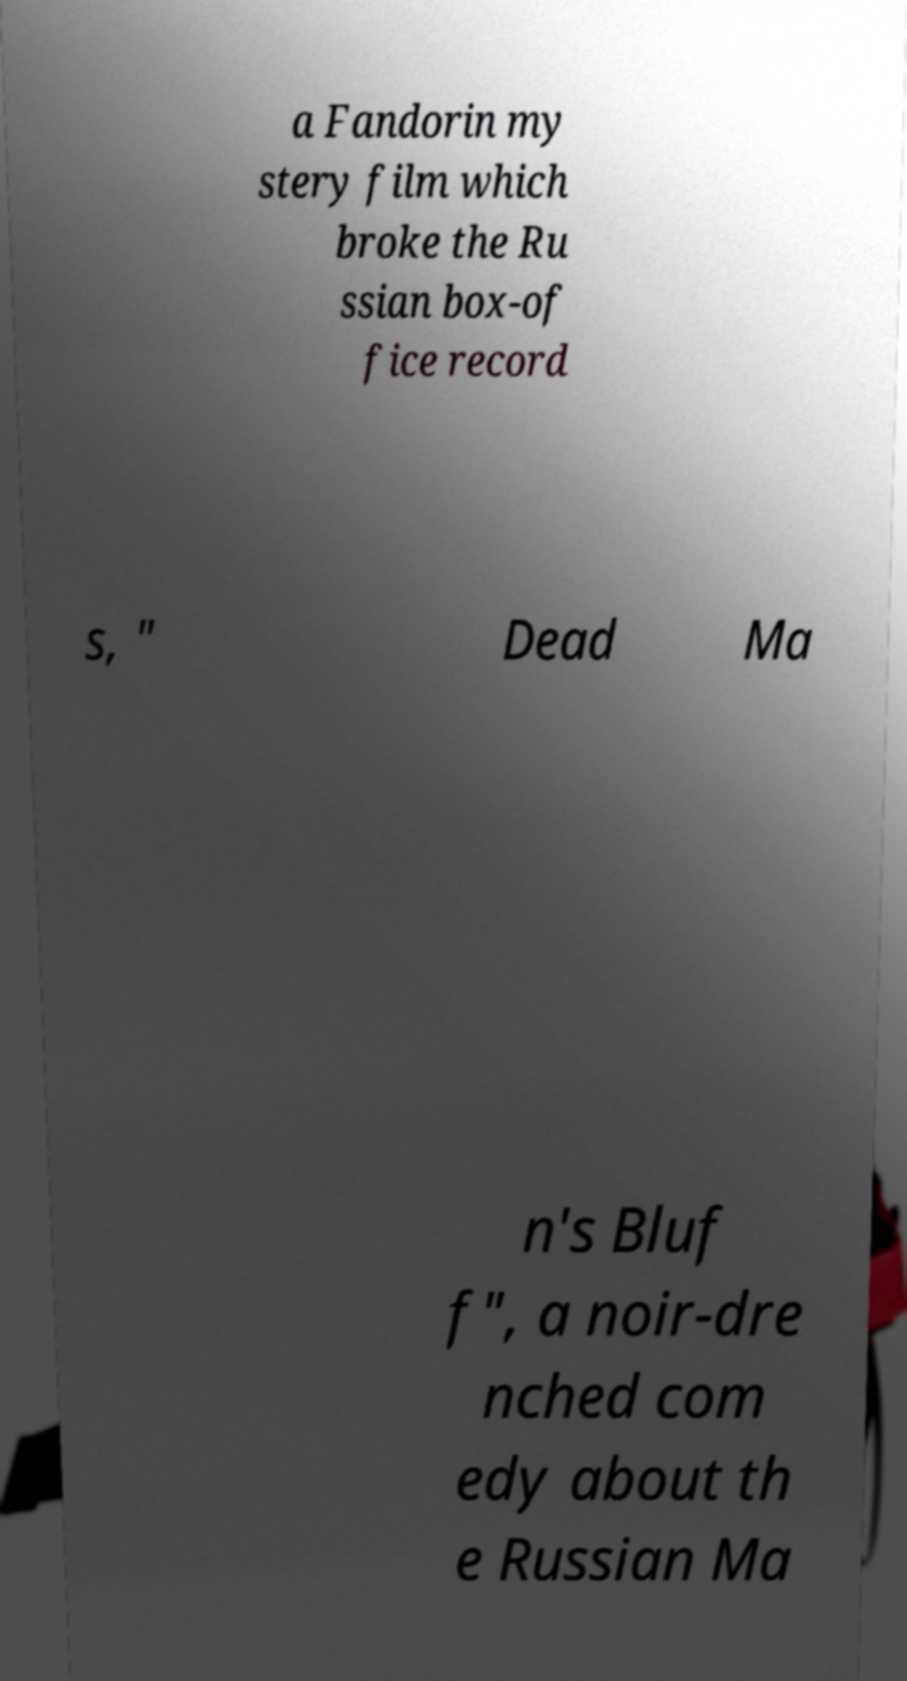Could you assist in decoding the text presented in this image and type it out clearly? a Fandorin my stery film which broke the Ru ssian box-of fice record s, " Dead Ma n's Bluf f", a noir-dre nched com edy about th e Russian Ma 